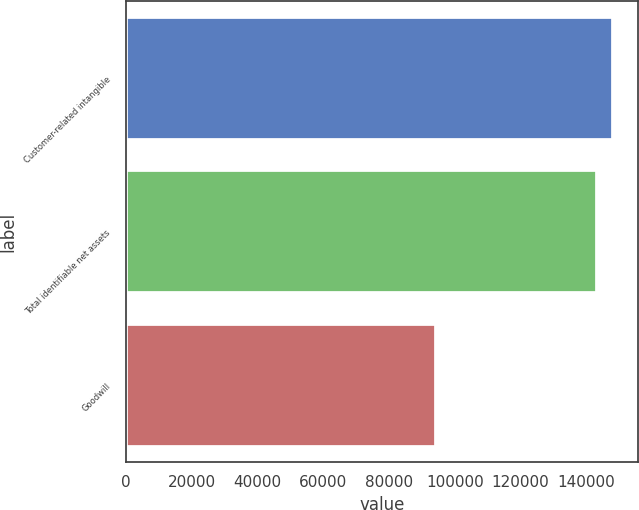<chart> <loc_0><loc_0><loc_500><loc_500><bar_chart><fcel>Customer-related intangible<fcel>Total identifiable net assets<fcel>Goodwill<nl><fcel>148165<fcel>143250<fcel>94250<nl></chart> 